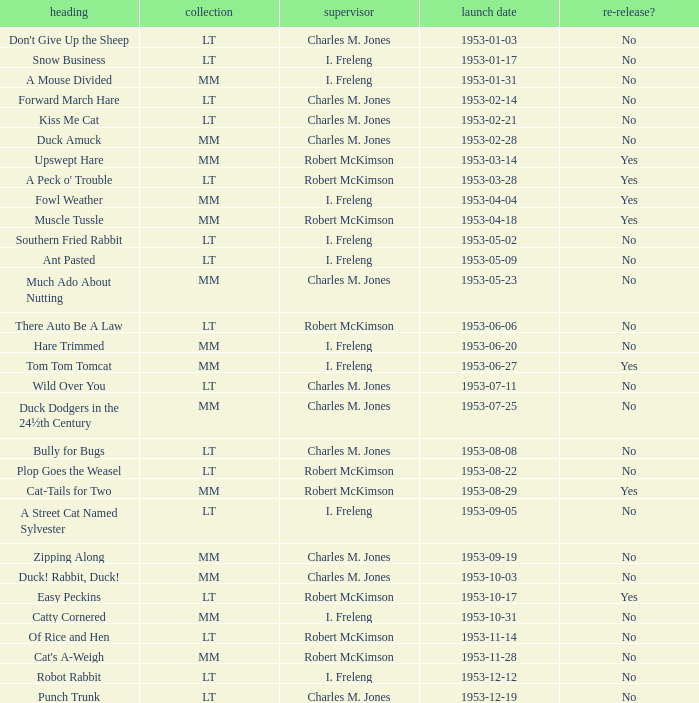What's the title for the release date of 1953-01-31 in the MM series, no reissue, and a director of I. Freleng? A Mouse Divided. 